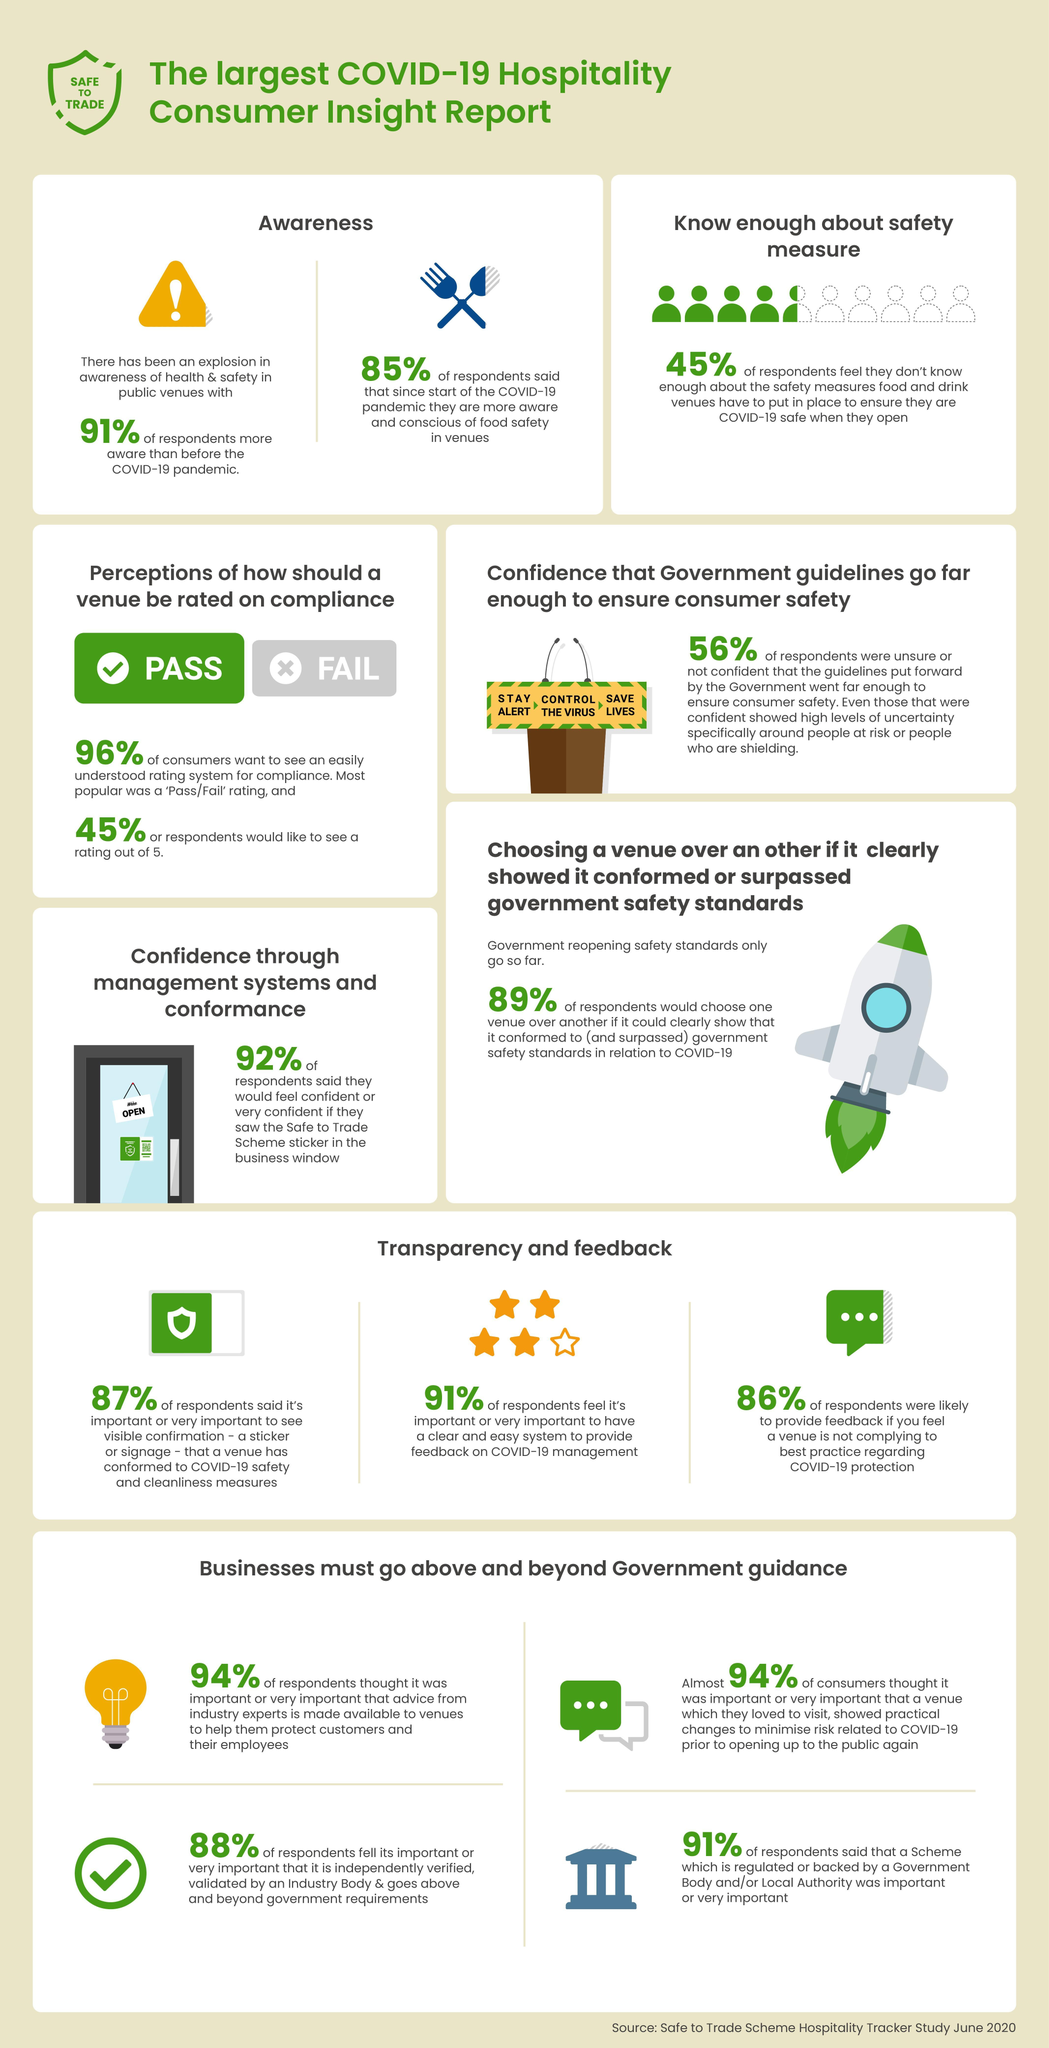What percentage of people do not know about the safety measures need to be taken while in cafeteria?
Answer the question with a short phrase. 45% How many columns have been listed under the heading "Transparency and Feedback" 3 What percentage of people was not assure on the safety measures taken by government to control pandemic? 56% What percentage of people are more conscious about safety and health after COVID 19 spread? 91% What percentage of people wanted normal star rating for the Pass/Fail system? 45% Which is the easiest rating system used by people? Pass/Fail 